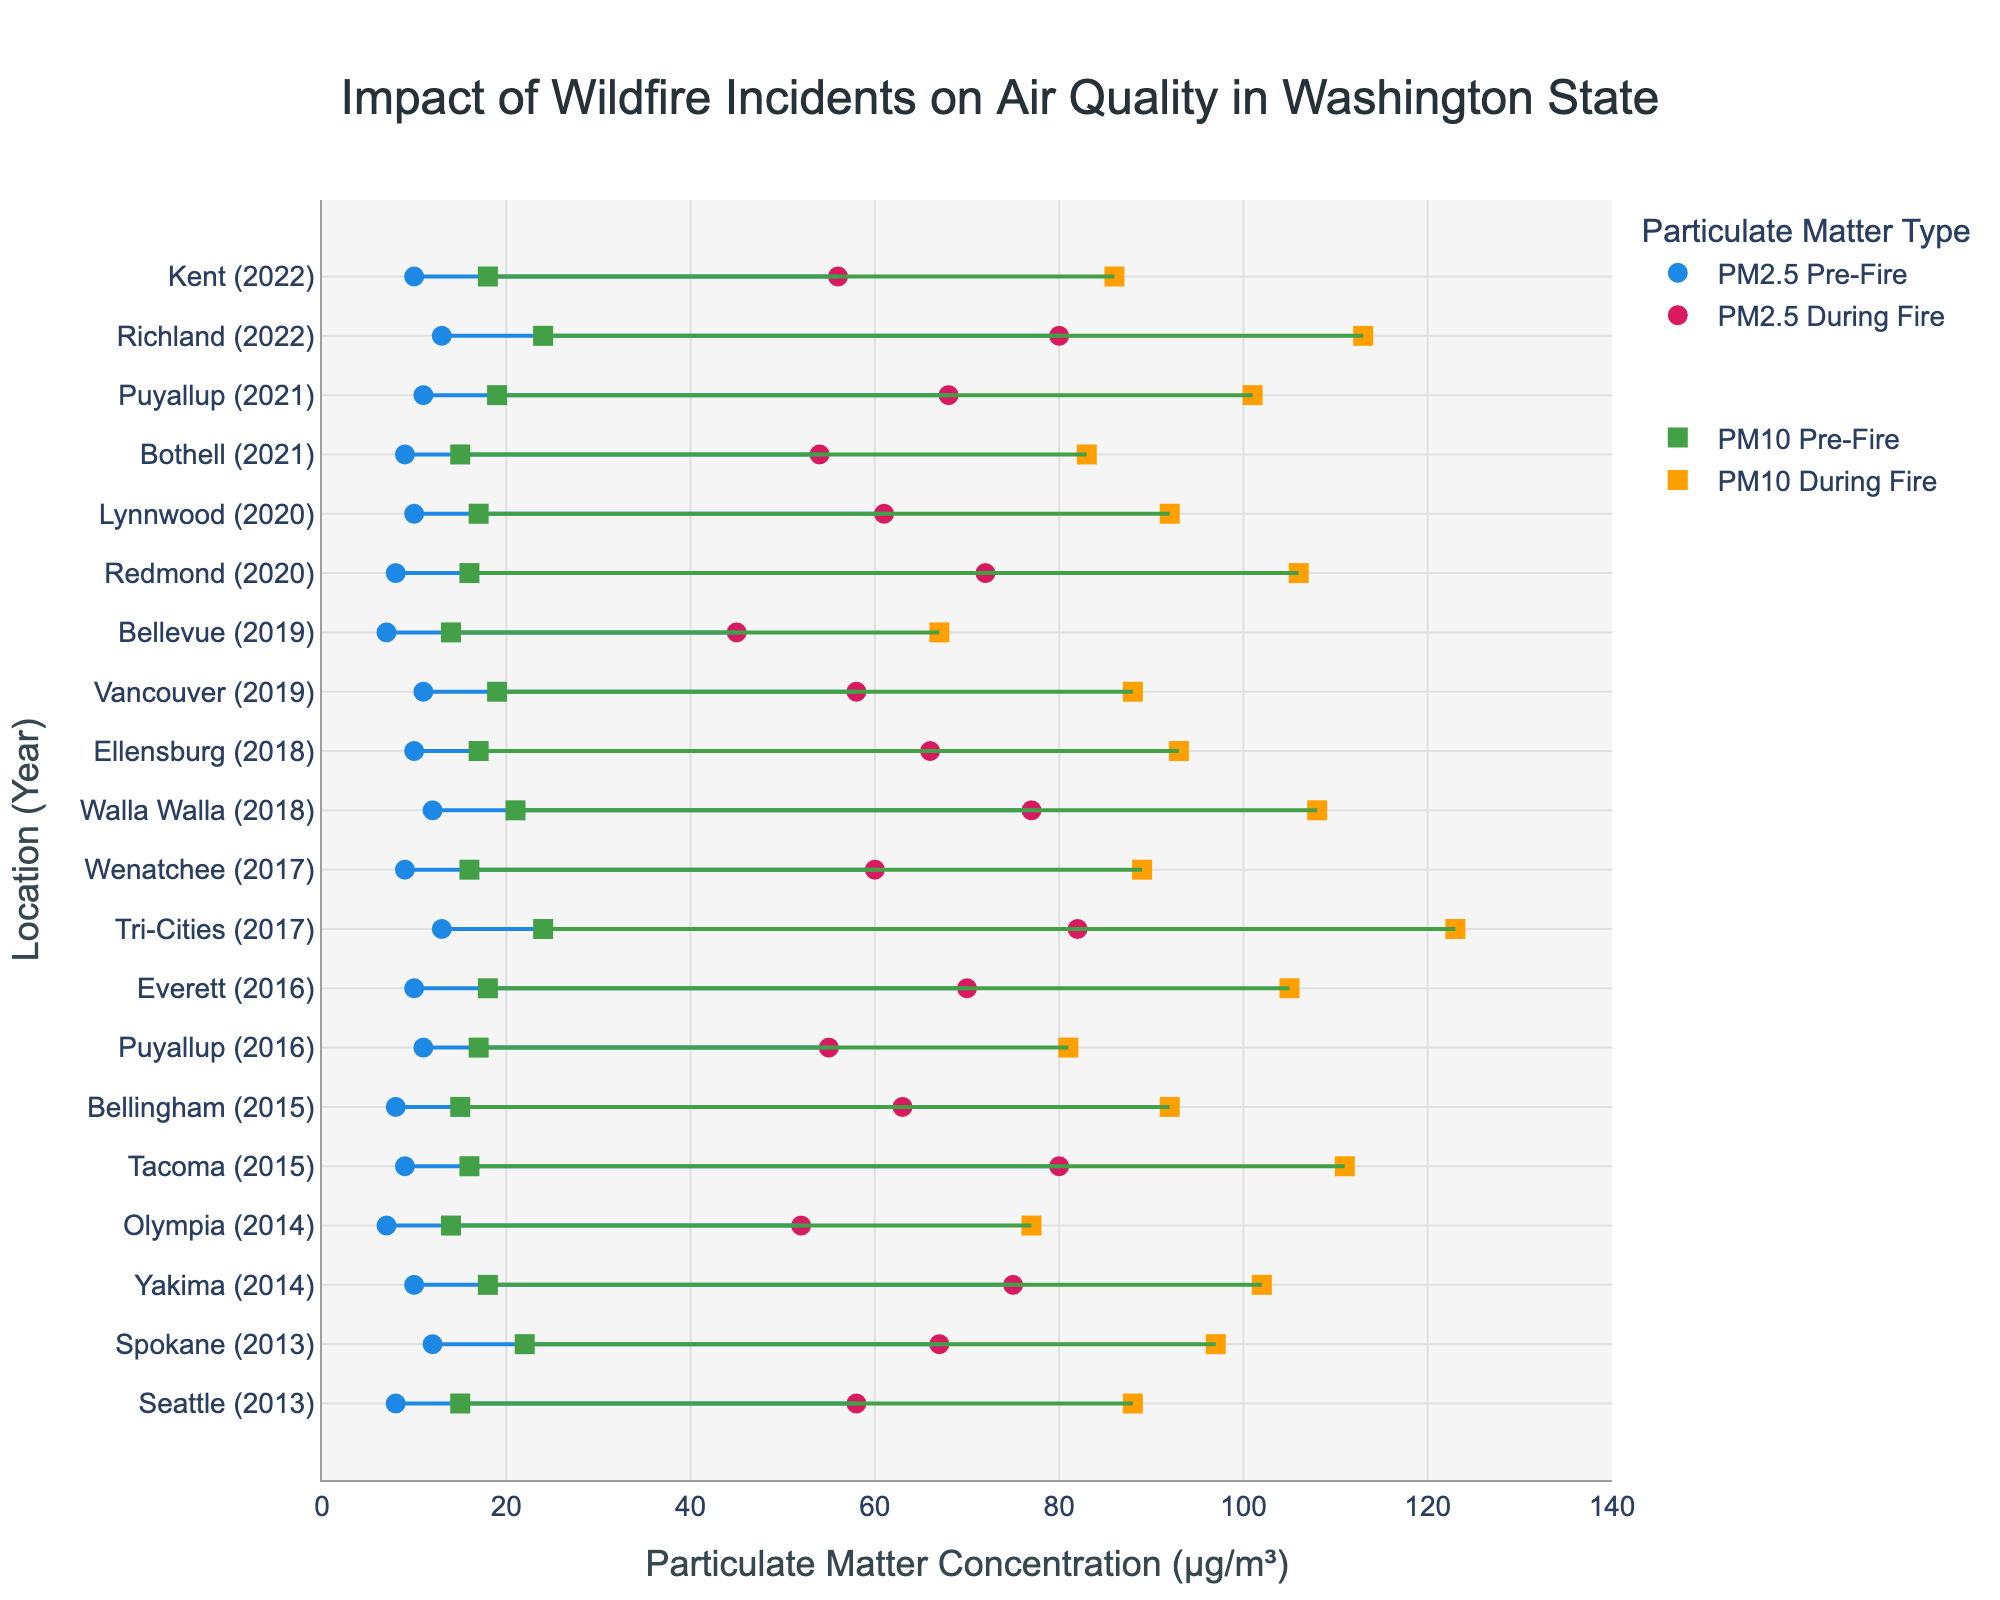What does the title of the plot indicate? The title "Impact of Wildfire Incidents on Air Quality in Washington State" suggests that the plot shows how wildfire incidents have affected the air quality, measured by particulate matter concentrations (PM2.5 and PM10), in various locations across Washington State over a certain period.
Answer: Impact of Wildfire Incidents on Air Quality in Washington State How many locations are represented in the plot? To find the number of locations, count each unique location/year pair along the y-axis. Each entry represents a different location and year combination.
Answer: 18 Which location had the highest PM2.5 concentration during a fire? Look for the highest PM2.5 value among the "During Fire" markers (red circles) along the x-axis. The marker corresponding to "Tri-Cities (2017)" has the highest PM2.5 concentration at 82 µg/m³.
Answer: Tri-Cities What was the PM10 concentration in Tacoma during the fire in 2015? Locate "Tacoma (2015)" on the y-axis and check its corresponding PM10 "During Fire" marker (yellow square) on the x-axis. The PM10 concentration was 111 µg/m³.
Answer: 111 µg/m³ What is the range of PM2.5 concentrations for the year 2018? Identify the minimum and maximum PM2.5 concentrations during and before fires for both locations in 2018 (Walla Walla and Ellensburg). The lowest PM2.5 concentration is 10 µg/m³ (pre-fire) and the highest is 77 µg/m³ (during fire).
Answer: 10–77 µg/m³ Which location experienced the biggest increase in PM10 concentration due to fire? Calculate the difference between pre-fire and during-fire PM10 concentrations for each location. "Tri-Cities (2017)" has the largest increase (123 - 24 = 99 µg/m³).
Answer: Tri-Cities How does the PM2.5 pre-fire concentration in Seattle compare to Bellevue? Find the pre-fire PM2.5 values for both "Seattle (2013)" and "Bellevue (2019)" and compare them. Seattle has 8 µg/m³, while Bellevue has 7 µg/m³.
Answer: Seattle is higher What is the average PM2.5 concentration during fires across all locations? Sum all PM2.5 during-fire concentrations and divide by the number of data points. (58 + 67 + 75 + 52 + 80 + 63 + 55 + 70 + 82 + 60 + 77 + 66 + 58 + 45 + 72 + 61 + 54 + 68 + 80 + 56) / 20 = 66.65 µg/m³.
Answer: 66.65 µg/m³ Has air quality worsened or improved over the years, based on the plot? Review the trends in PM2.5 and PM10 concentrations over time. The general trend indicates worsening air quality during fires, as both PM2.5 and PM10 concentrations increase significantly during fires across the years.
Answer: Worsened 